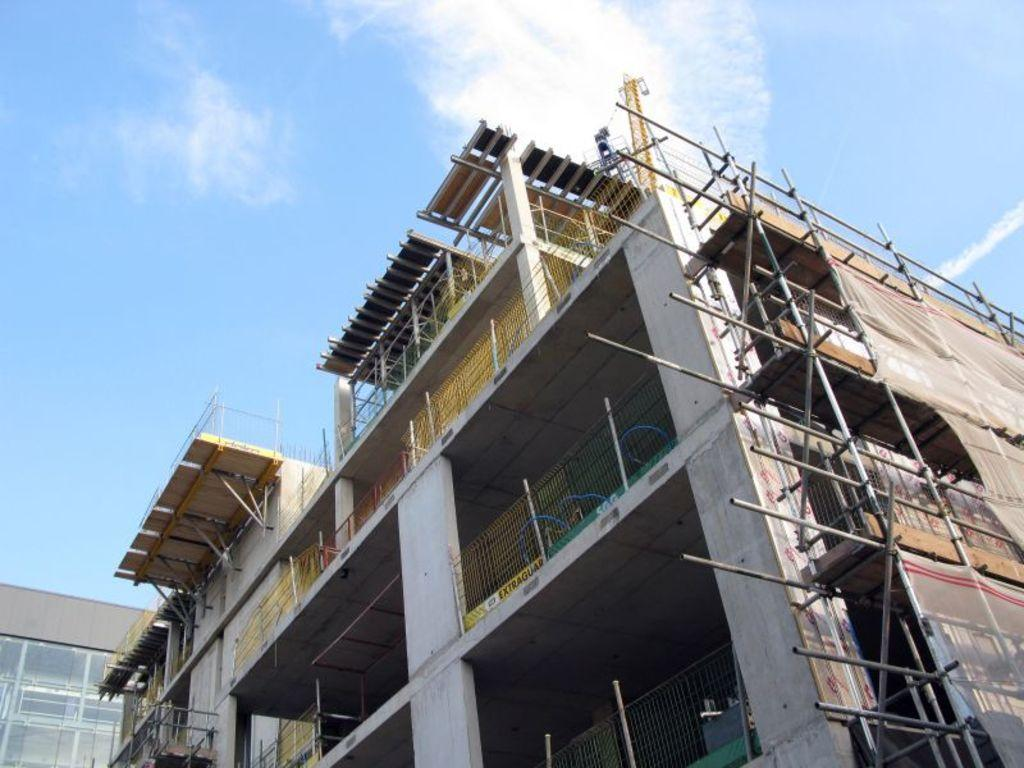What type of structures can be seen in the image? There are buildings in the image. What material is visible in the image? There are iron rods in the image. What is the condition of the sky in the image? The sky is cloudy in the image. What type of verse can be heard being recited during the protest in the image? There is no protest or verse present in the image; it only features buildings, iron rods, and a cloudy sky. 